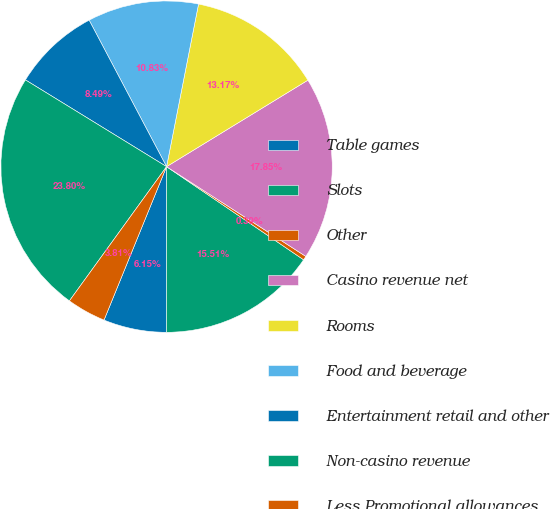Convert chart to OTSL. <chart><loc_0><loc_0><loc_500><loc_500><pie_chart><fcel>Table games<fcel>Slots<fcel>Other<fcel>Casino revenue net<fcel>Rooms<fcel>Food and beverage<fcel>Entertainment retail and other<fcel>Non-casino revenue<fcel>Less Promotional allowances<nl><fcel>6.15%<fcel>15.51%<fcel>0.39%<fcel>17.85%<fcel>13.17%<fcel>10.83%<fcel>8.49%<fcel>23.8%<fcel>3.81%<nl></chart> 